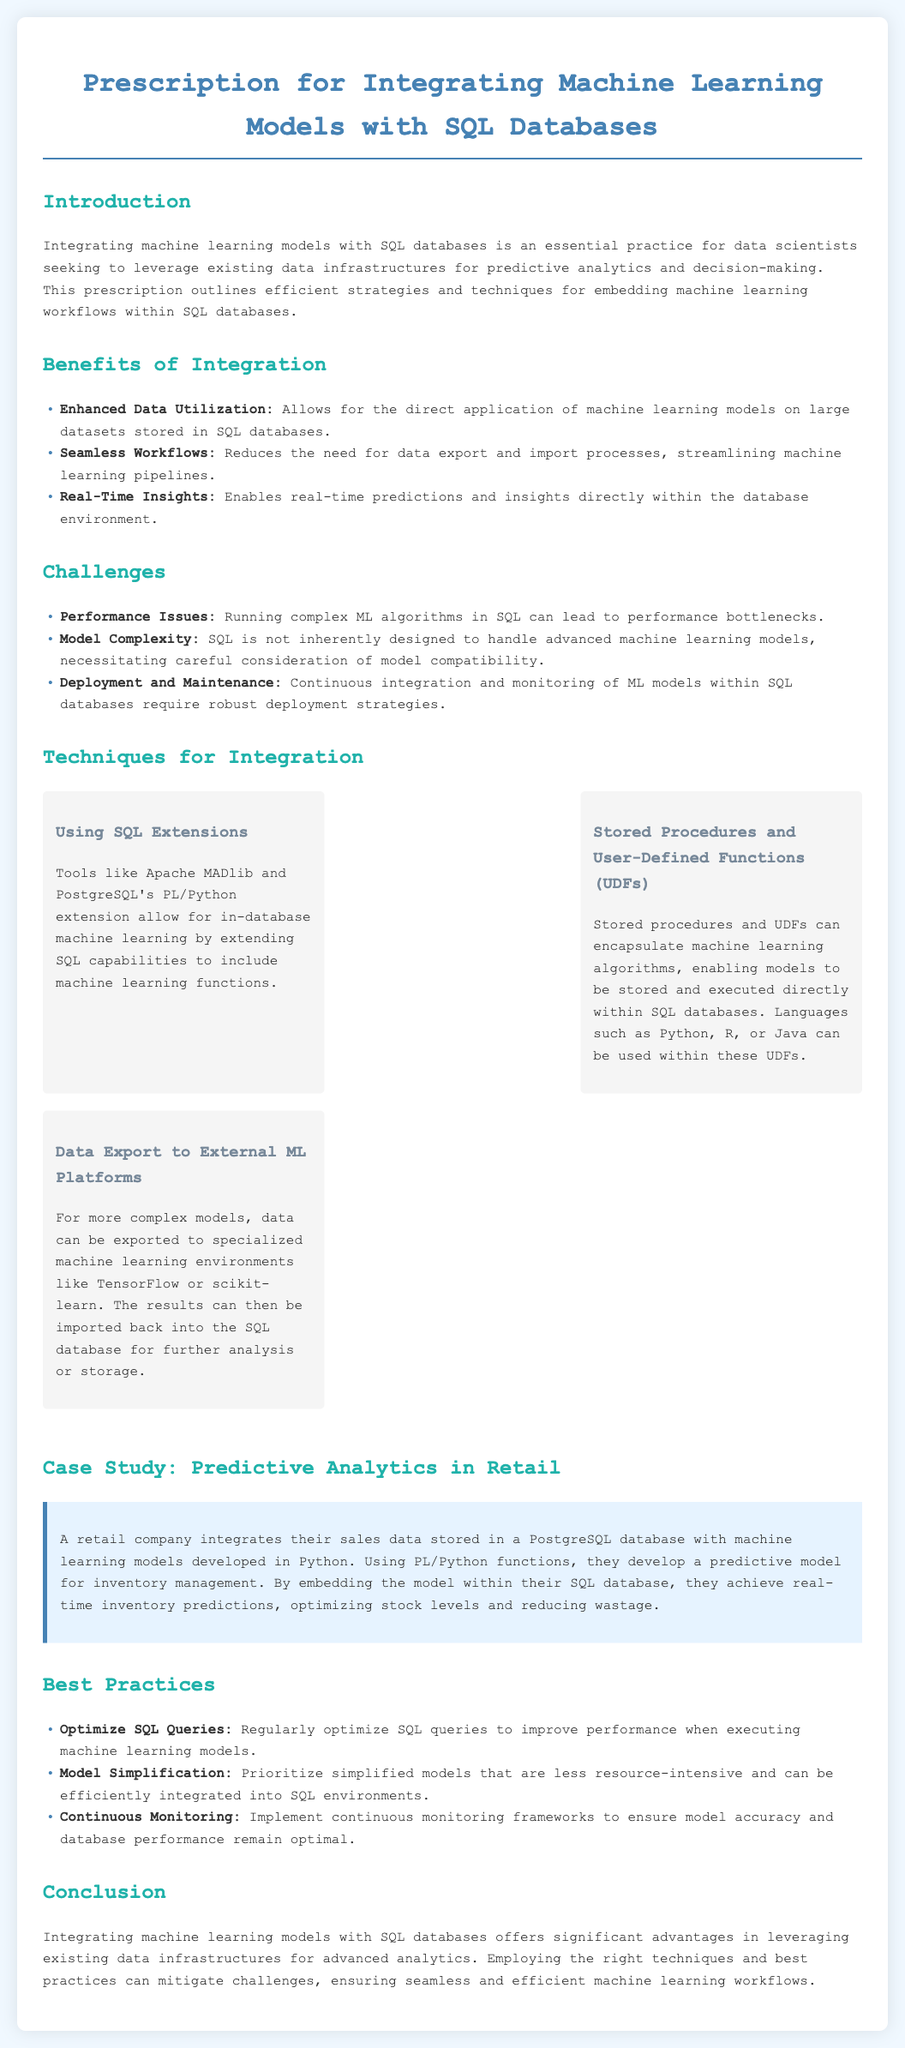What is the title of the document? The title is prominently displayed at the top of the document, indicating the main focus of the content.
Answer: Prescription for Integrating Machine Learning Models with SQL Databases What are two benefits of integrating machine learning with SQL databases? The benefits are explicitly listed in the document under the "Benefits of Integration" section.
Answer: Enhanced Data Utilization, Seamless Workflows What is one challenge of integrating machine learning models with SQL databases? The challenges are documented in the specified section, highlighting potential issues faced during integration.
Answer: Performance Issues Which technique uses stored procedures to integrate machine learning? The document categorizes techniques and explains them briefly, noting how they relate to SQL operations.
Answer: Stored Procedures and User-Defined Functions (UDFs) What is a key best practice mentioned for optimizing SQL queries? Best practices are clearly provided in the corresponding section, showing recommended actions for effective integration.
Answer: Optimize SQL Queries In the case study, what type of business is discussed? The case study section includes a real-world application of the discussed concepts, indicating the industry involved.
Answer: Retail How does the retail company use their machine learning model? The description in the case study details the practical application of the model, emphasizing its purpose.
Answer: Inventory management What is the role of PL/Python in the case study? The document explains specific implementations and tools used in the case study to illustrate integration.
Answer: Develop a predictive model What is the primary goal of integrating machine learning models with SQL databases? The introduction provides insight into the overall objective of the integration practice discussed in the document.
Answer: Leverage existing data infrastructures for predictive analytics 